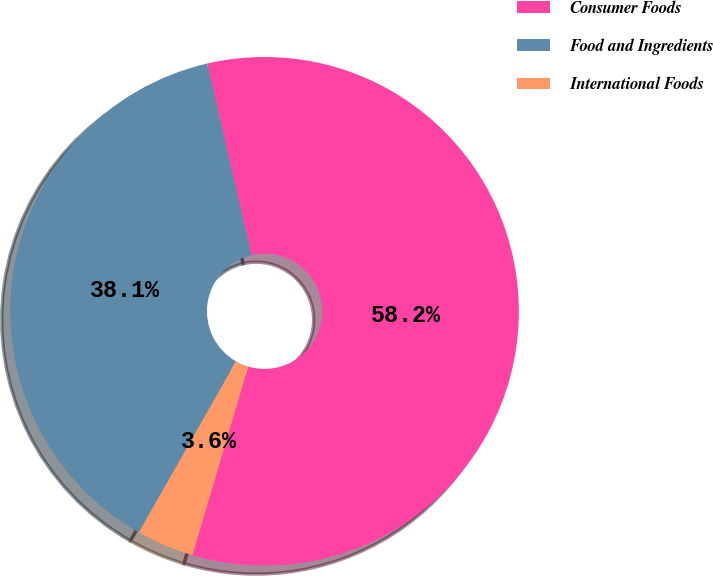<chart> <loc_0><loc_0><loc_500><loc_500><pie_chart><fcel>Consumer Foods<fcel>Food and Ingredients<fcel>International Foods<nl><fcel>58.2%<fcel>38.15%<fcel>3.65%<nl></chart> 